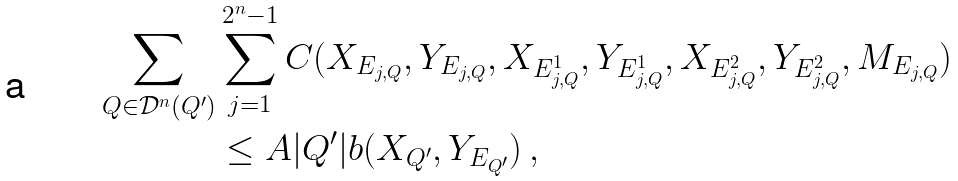Convert formula to latex. <formula><loc_0><loc_0><loc_500><loc_500>\sum _ { Q \in \mathcal { D } ^ { n } ( Q ^ { \prime } ) } & \sum _ { j = 1 } ^ { 2 ^ { n } - 1 } C ( X _ { E _ { j , Q } } , Y _ { E _ { j , Q } } , X _ { E ^ { 1 } _ { j , Q } } , Y _ { E ^ { 1 } _ { j , Q } } , X _ { E ^ { 2 } _ { j , Q } } , Y _ { E ^ { 2 } _ { j , Q } } , M _ { E _ { j , Q } } ) \\ & \leq A | Q ^ { \prime } | b ( X _ { Q ^ { \prime } } , Y _ { E _ { Q ^ { \prime } } } ) \, ,</formula> 